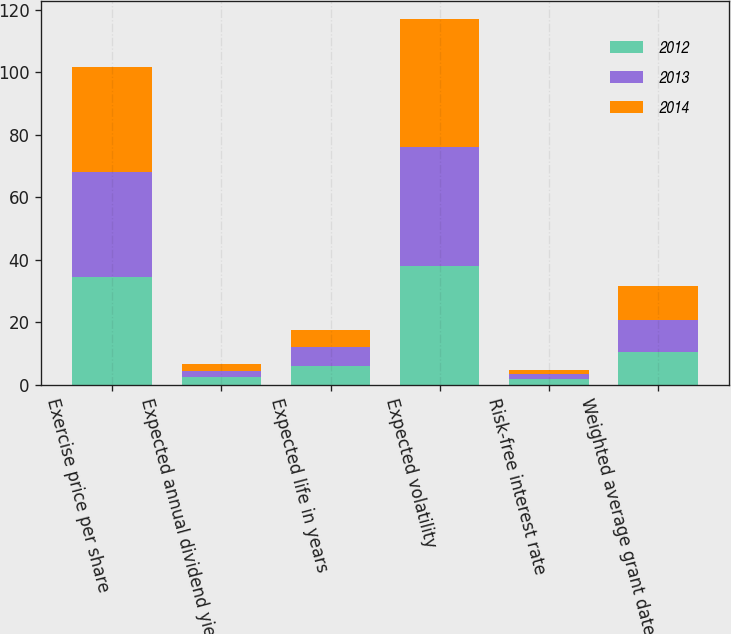Convert chart. <chart><loc_0><loc_0><loc_500><loc_500><stacked_bar_chart><ecel><fcel>Exercise price per share<fcel>Expected annual dividend yield<fcel>Expected life in years<fcel>Expected volatility<fcel>Risk-free interest rate<fcel>Weighted average grant date<nl><fcel>2012<fcel>34.49<fcel>2.3<fcel>5.9<fcel>38<fcel>1.8<fcel>10.5<nl><fcel>2013<fcel>33.54<fcel>2.1<fcel>6.1<fcel>38<fcel>1.6<fcel>10.25<nl><fcel>2014<fcel>33.52<fcel>2.2<fcel>5.5<fcel>41<fcel>1.2<fcel>10.86<nl></chart> 